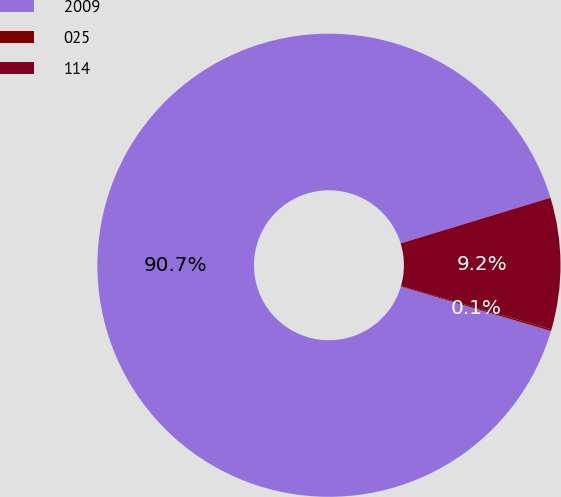Convert chart. <chart><loc_0><loc_0><loc_500><loc_500><pie_chart><fcel>2009<fcel>025<fcel>114<nl><fcel>90.71%<fcel>0.12%<fcel>9.17%<nl></chart> 